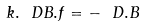Convert formula to latex. <formula><loc_0><loc_0><loc_500><loc_500>k . \ D B . f = - \ D . B</formula> 